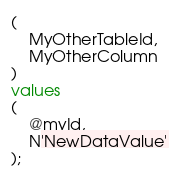Convert code to text. <code><loc_0><loc_0><loc_500><loc_500><_SQL_>(
	MyOtherTableId,
	MyOtherColumn
)
values
(
	@myId,
	N'NewDataValue'
);</code> 